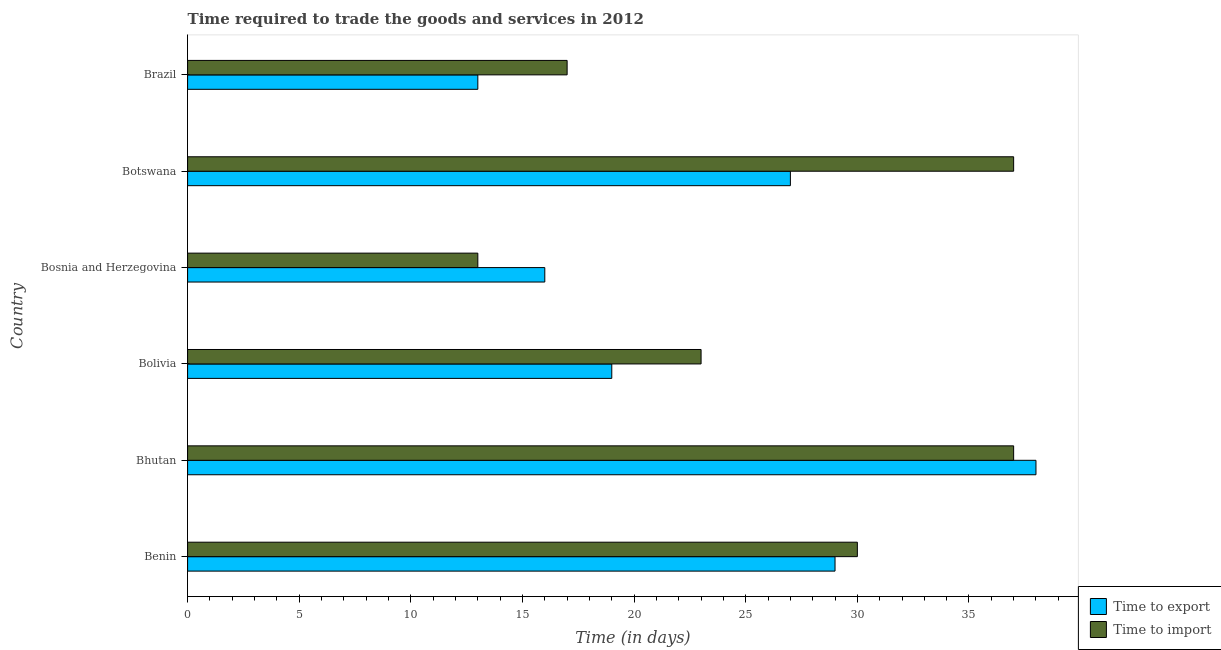Are the number of bars per tick equal to the number of legend labels?
Give a very brief answer. Yes. How many bars are there on the 2nd tick from the top?
Ensure brevity in your answer.  2. What is the label of the 3rd group of bars from the top?
Provide a short and direct response. Bosnia and Herzegovina. What is the time to export in Botswana?
Your response must be concise. 27. Across all countries, what is the maximum time to import?
Provide a succinct answer. 37. In which country was the time to export maximum?
Make the answer very short. Bhutan. What is the total time to import in the graph?
Provide a succinct answer. 157. What is the average time to export per country?
Offer a terse response. 23.67. Is the time to export in Benin less than that in Bolivia?
Your response must be concise. No. Is the difference between the time to export in Bolivia and Botswana greater than the difference between the time to import in Bolivia and Botswana?
Your answer should be compact. Yes. In how many countries, is the time to import greater than the average time to import taken over all countries?
Ensure brevity in your answer.  3. What does the 2nd bar from the top in Benin represents?
Provide a short and direct response. Time to export. What does the 2nd bar from the bottom in Bolivia represents?
Your response must be concise. Time to import. How many bars are there?
Offer a very short reply. 12. Are all the bars in the graph horizontal?
Your answer should be very brief. Yes. How many countries are there in the graph?
Provide a short and direct response. 6. Are the values on the major ticks of X-axis written in scientific E-notation?
Offer a terse response. No. Does the graph contain grids?
Provide a short and direct response. No. How many legend labels are there?
Your answer should be compact. 2. How are the legend labels stacked?
Provide a short and direct response. Vertical. What is the title of the graph?
Your response must be concise. Time required to trade the goods and services in 2012. Does "Diesel" appear as one of the legend labels in the graph?
Ensure brevity in your answer.  No. What is the label or title of the X-axis?
Your answer should be compact. Time (in days). What is the label or title of the Y-axis?
Your response must be concise. Country. What is the Time (in days) in Time to import in Benin?
Provide a succinct answer. 30. What is the Time (in days) of Time to import in Bhutan?
Your response must be concise. 37. What is the Time (in days) in Time to export in Bosnia and Herzegovina?
Give a very brief answer. 16. What is the Time (in days) in Time to import in Bosnia and Herzegovina?
Keep it short and to the point. 13. What is the Time (in days) of Time to export in Botswana?
Keep it short and to the point. 27. What is the Time (in days) in Time to import in Botswana?
Offer a terse response. 37. Across all countries, what is the maximum Time (in days) in Time to export?
Offer a very short reply. 38. Across all countries, what is the maximum Time (in days) in Time to import?
Your answer should be very brief. 37. Across all countries, what is the minimum Time (in days) in Time to export?
Make the answer very short. 13. Across all countries, what is the minimum Time (in days) in Time to import?
Offer a terse response. 13. What is the total Time (in days) of Time to export in the graph?
Your answer should be very brief. 142. What is the total Time (in days) in Time to import in the graph?
Provide a short and direct response. 157. What is the difference between the Time (in days) in Time to export in Benin and that in Bhutan?
Your answer should be very brief. -9. What is the difference between the Time (in days) of Time to import in Benin and that in Bolivia?
Your answer should be compact. 7. What is the difference between the Time (in days) of Time to import in Benin and that in Bosnia and Herzegovina?
Provide a succinct answer. 17. What is the difference between the Time (in days) in Time to import in Benin and that in Botswana?
Your response must be concise. -7. What is the difference between the Time (in days) of Time to import in Bhutan and that in Bosnia and Herzegovina?
Make the answer very short. 24. What is the difference between the Time (in days) of Time to export in Bhutan and that in Botswana?
Offer a terse response. 11. What is the difference between the Time (in days) in Time to import in Bhutan and that in Brazil?
Keep it short and to the point. 20. What is the difference between the Time (in days) in Time to export in Bolivia and that in Bosnia and Herzegovina?
Your response must be concise. 3. What is the difference between the Time (in days) of Time to import in Bolivia and that in Bosnia and Herzegovina?
Provide a short and direct response. 10. What is the difference between the Time (in days) in Time to export in Bolivia and that in Botswana?
Make the answer very short. -8. What is the difference between the Time (in days) of Time to import in Bolivia and that in Botswana?
Provide a succinct answer. -14. What is the difference between the Time (in days) in Time to export in Bolivia and that in Brazil?
Ensure brevity in your answer.  6. What is the difference between the Time (in days) in Time to export in Bosnia and Herzegovina and that in Botswana?
Your answer should be very brief. -11. What is the difference between the Time (in days) in Time to export in Bosnia and Herzegovina and that in Brazil?
Keep it short and to the point. 3. What is the difference between the Time (in days) of Time to export in Botswana and that in Brazil?
Ensure brevity in your answer.  14. What is the difference between the Time (in days) in Time to export in Benin and the Time (in days) in Time to import in Botswana?
Provide a succinct answer. -8. What is the difference between the Time (in days) in Time to export in Bhutan and the Time (in days) in Time to import in Bolivia?
Your answer should be very brief. 15. What is the difference between the Time (in days) in Time to export in Bhutan and the Time (in days) in Time to import in Botswana?
Keep it short and to the point. 1. What is the difference between the Time (in days) in Time to export in Bhutan and the Time (in days) in Time to import in Brazil?
Offer a terse response. 21. What is the difference between the Time (in days) of Time to export in Bolivia and the Time (in days) of Time to import in Bosnia and Herzegovina?
Your answer should be compact. 6. What is the difference between the Time (in days) in Time to export in Bolivia and the Time (in days) in Time to import in Botswana?
Ensure brevity in your answer.  -18. What is the difference between the Time (in days) in Time to export in Bolivia and the Time (in days) in Time to import in Brazil?
Your answer should be compact. 2. What is the average Time (in days) in Time to export per country?
Offer a very short reply. 23.67. What is the average Time (in days) of Time to import per country?
Give a very brief answer. 26.17. What is the difference between the Time (in days) of Time to export and Time (in days) of Time to import in Bolivia?
Your response must be concise. -4. What is the difference between the Time (in days) of Time to export and Time (in days) of Time to import in Bosnia and Herzegovina?
Make the answer very short. 3. What is the ratio of the Time (in days) in Time to export in Benin to that in Bhutan?
Keep it short and to the point. 0.76. What is the ratio of the Time (in days) in Time to import in Benin to that in Bhutan?
Make the answer very short. 0.81. What is the ratio of the Time (in days) in Time to export in Benin to that in Bolivia?
Keep it short and to the point. 1.53. What is the ratio of the Time (in days) of Time to import in Benin to that in Bolivia?
Offer a very short reply. 1.3. What is the ratio of the Time (in days) of Time to export in Benin to that in Bosnia and Herzegovina?
Offer a terse response. 1.81. What is the ratio of the Time (in days) in Time to import in Benin to that in Bosnia and Herzegovina?
Make the answer very short. 2.31. What is the ratio of the Time (in days) in Time to export in Benin to that in Botswana?
Offer a very short reply. 1.07. What is the ratio of the Time (in days) in Time to import in Benin to that in Botswana?
Your answer should be compact. 0.81. What is the ratio of the Time (in days) of Time to export in Benin to that in Brazil?
Keep it short and to the point. 2.23. What is the ratio of the Time (in days) of Time to import in Benin to that in Brazil?
Ensure brevity in your answer.  1.76. What is the ratio of the Time (in days) of Time to export in Bhutan to that in Bolivia?
Your response must be concise. 2. What is the ratio of the Time (in days) in Time to import in Bhutan to that in Bolivia?
Provide a short and direct response. 1.61. What is the ratio of the Time (in days) in Time to export in Bhutan to that in Bosnia and Herzegovina?
Your response must be concise. 2.38. What is the ratio of the Time (in days) of Time to import in Bhutan to that in Bosnia and Herzegovina?
Keep it short and to the point. 2.85. What is the ratio of the Time (in days) of Time to export in Bhutan to that in Botswana?
Keep it short and to the point. 1.41. What is the ratio of the Time (in days) in Time to export in Bhutan to that in Brazil?
Your response must be concise. 2.92. What is the ratio of the Time (in days) in Time to import in Bhutan to that in Brazil?
Your answer should be very brief. 2.18. What is the ratio of the Time (in days) in Time to export in Bolivia to that in Bosnia and Herzegovina?
Keep it short and to the point. 1.19. What is the ratio of the Time (in days) in Time to import in Bolivia to that in Bosnia and Herzegovina?
Ensure brevity in your answer.  1.77. What is the ratio of the Time (in days) in Time to export in Bolivia to that in Botswana?
Your answer should be very brief. 0.7. What is the ratio of the Time (in days) of Time to import in Bolivia to that in Botswana?
Your answer should be compact. 0.62. What is the ratio of the Time (in days) in Time to export in Bolivia to that in Brazil?
Your answer should be very brief. 1.46. What is the ratio of the Time (in days) of Time to import in Bolivia to that in Brazil?
Make the answer very short. 1.35. What is the ratio of the Time (in days) of Time to export in Bosnia and Herzegovina to that in Botswana?
Provide a succinct answer. 0.59. What is the ratio of the Time (in days) of Time to import in Bosnia and Herzegovina to that in Botswana?
Offer a very short reply. 0.35. What is the ratio of the Time (in days) in Time to export in Bosnia and Herzegovina to that in Brazil?
Provide a short and direct response. 1.23. What is the ratio of the Time (in days) of Time to import in Bosnia and Herzegovina to that in Brazil?
Ensure brevity in your answer.  0.76. What is the ratio of the Time (in days) of Time to export in Botswana to that in Brazil?
Provide a short and direct response. 2.08. What is the ratio of the Time (in days) of Time to import in Botswana to that in Brazil?
Keep it short and to the point. 2.18. What is the difference between the highest and the second highest Time (in days) of Time to export?
Offer a very short reply. 9. 